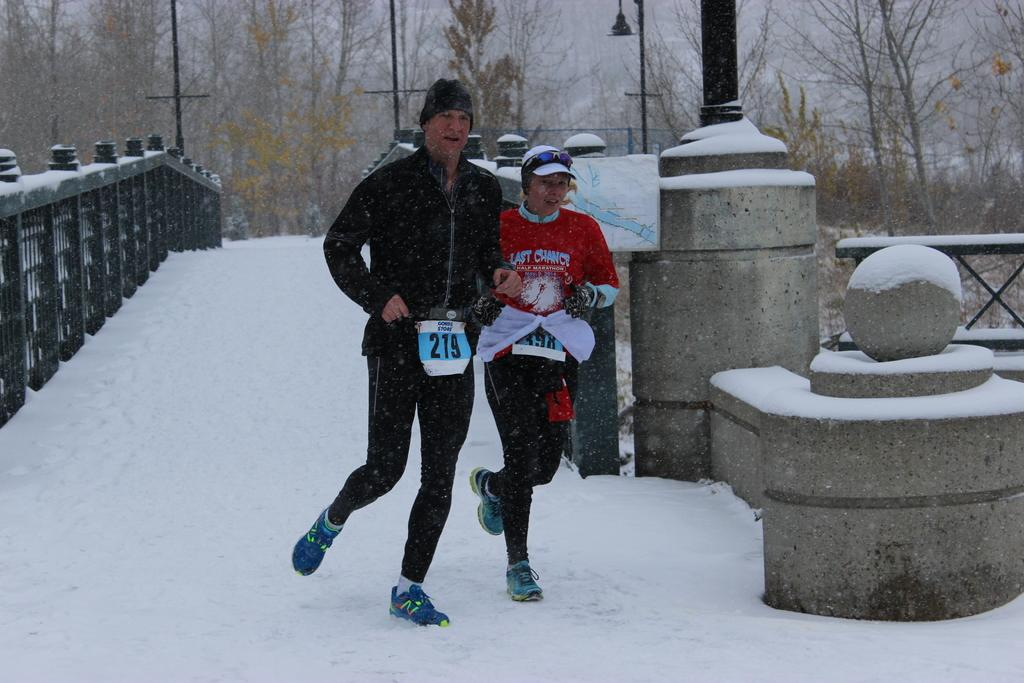<image>
Summarize the visual content of the image. A pair of runners in the snow with wearing the numbers 219 & 398. 